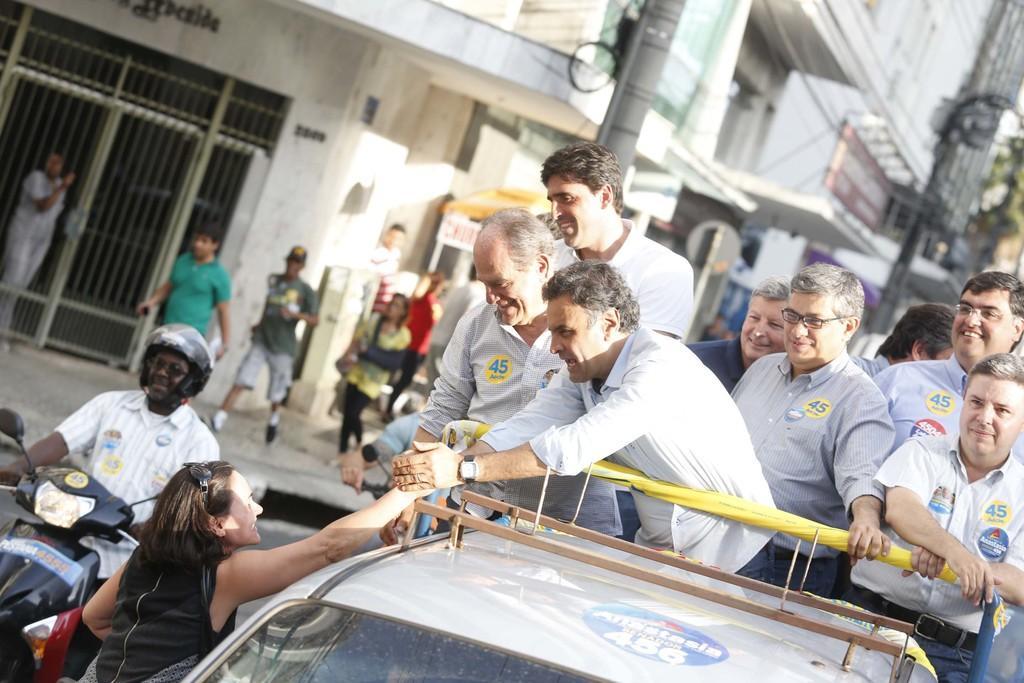In one or two sentences, can you explain what this image depicts? There are group of standing and smiling on the truck. Here is the woman hand shaking. This looks like a car. This is the man wearing helmet and riding motorbike. There are few people walking. These are the buildings. This looks like a current pole. This is a gate. 